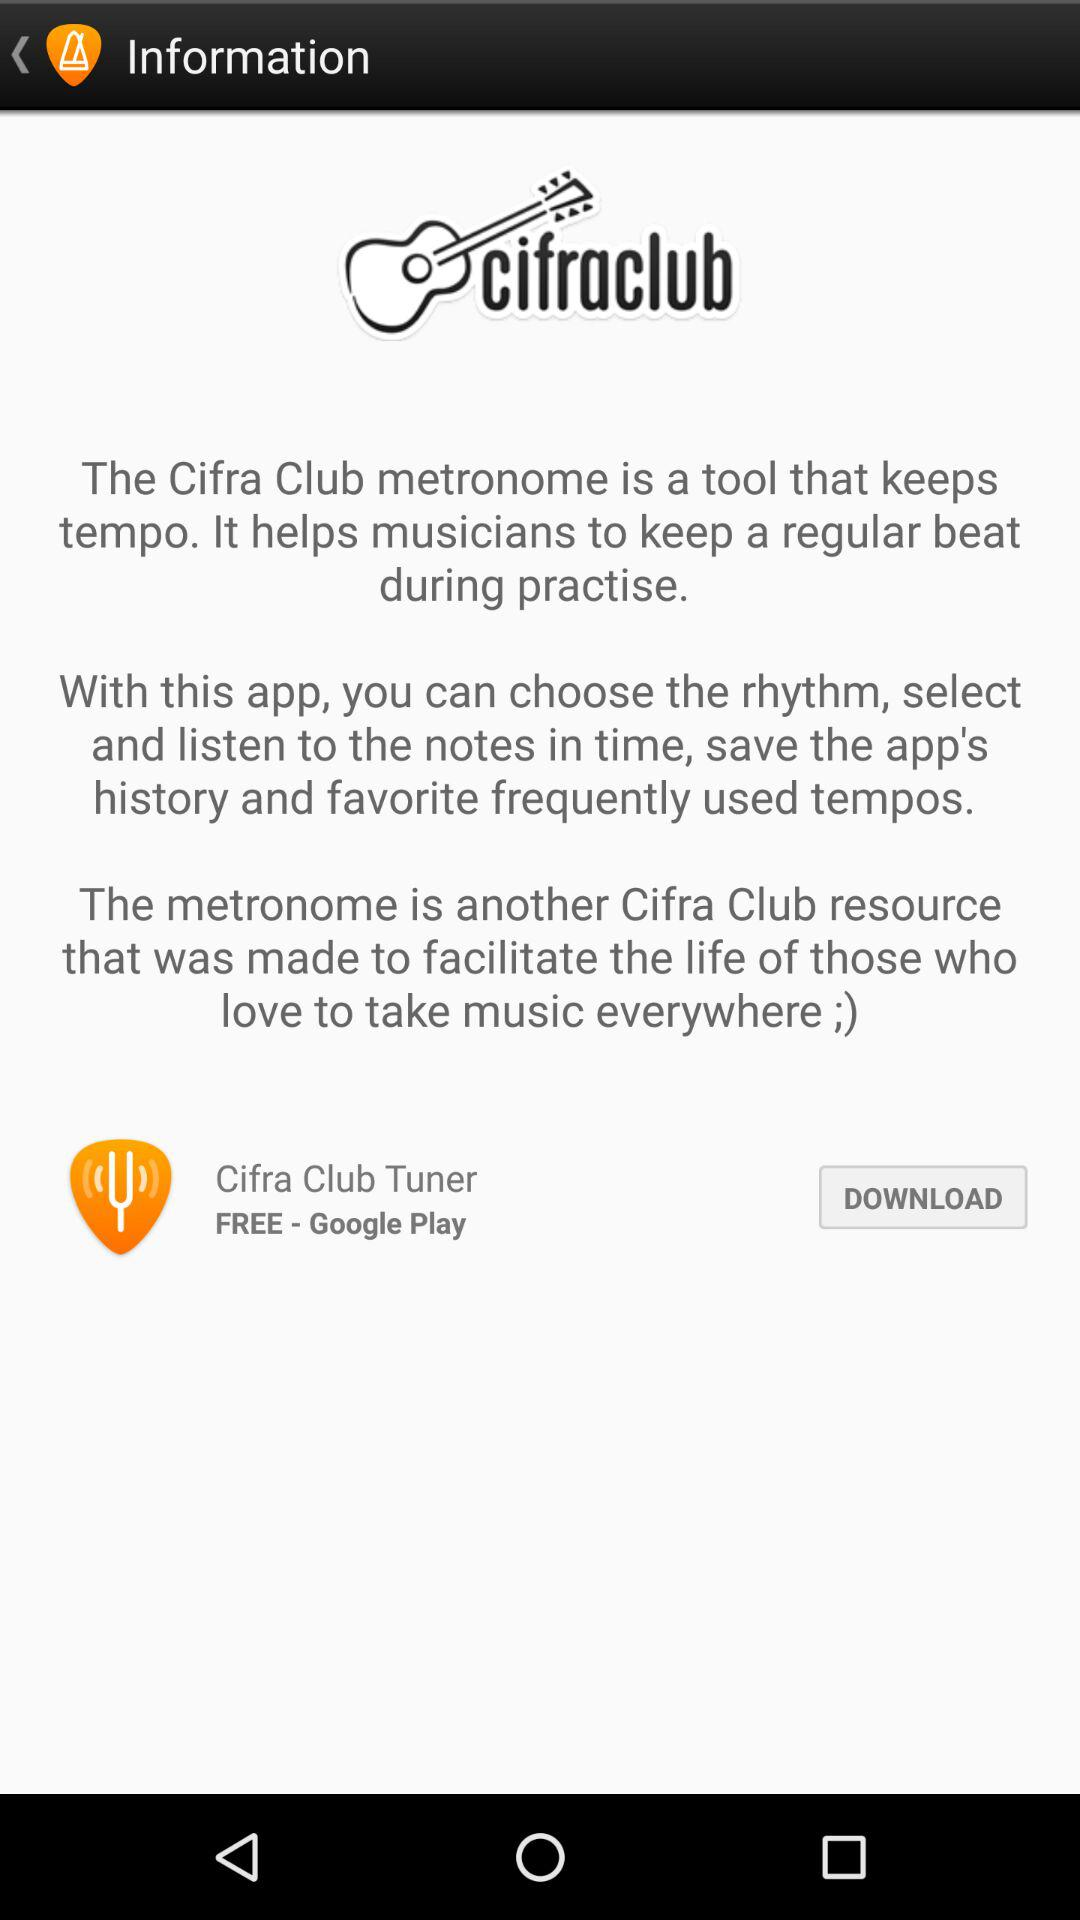What is the use of the "Cifra Club" metronome? The "Cifra Club" metronome is a tool that keeps tempo. It helps musicians to keep a regular beat during practice. 